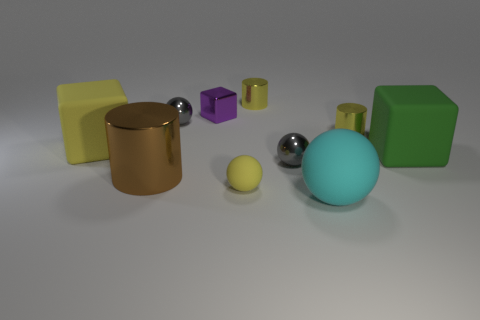Is the material of the big brown thing the same as the tiny yellow object in front of the large green object?
Keep it short and to the point. No. Are there the same number of cylinders in front of the big matte sphere and metallic cylinders that are right of the brown shiny object?
Ensure brevity in your answer.  No. What material is the large brown object?
Provide a succinct answer. Metal. The rubber thing that is the same size as the purple block is what color?
Make the answer very short. Yellow. There is a small object in front of the brown shiny thing; are there any brown things that are behind it?
Keep it short and to the point. Yes. What number of cubes are either large cyan rubber objects or large brown shiny things?
Provide a succinct answer. 0. There is a gray metallic sphere on the right side of the tiny yellow thing in front of the large rubber block that is on the right side of the large yellow rubber thing; how big is it?
Make the answer very short. Small. Are there any tiny metal cylinders behind the large yellow rubber cube?
Offer a terse response. Yes. The other matte thing that is the same color as the small rubber thing is what shape?
Offer a terse response. Cube. How many things are either small yellow rubber things right of the large brown cylinder or large green spheres?
Offer a very short reply. 1. 